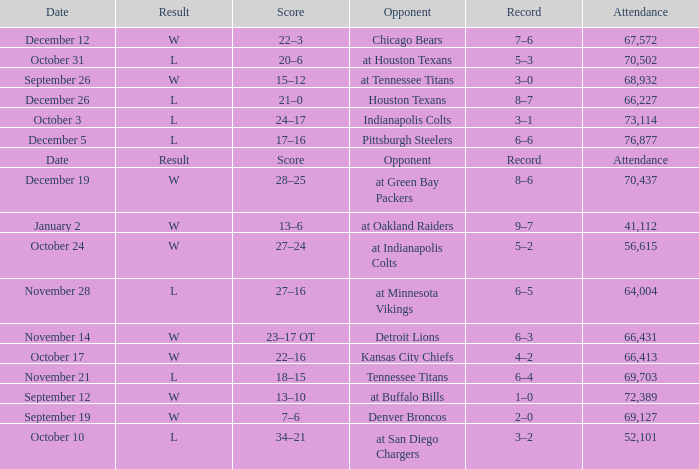What record has w as the result, with January 2 as the date? 9–7. Give me the full table as a dictionary. {'header': ['Date', 'Result', 'Score', 'Opponent', 'Record', 'Attendance'], 'rows': [['December 12', 'W', '22–3', 'Chicago Bears', '7–6', '67,572'], ['October 31', 'L', '20–6', 'at Houston Texans', '5–3', '70,502'], ['September 26', 'W', '15–12', 'at Tennessee Titans', '3–0', '68,932'], ['December 26', 'L', '21–0', 'Houston Texans', '8–7', '66,227'], ['October 3', 'L', '24–17', 'Indianapolis Colts', '3–1', '73,114'], ['December 5', 'L', '17–16', 'Pittsburgh Steelers', '6–6', '76,877'], ['Date', 'Result', 'Score', 'Opponent', 'Record', 'Attendance'], ['December 19', 'W', '28–25', 'at Green Bay Packers', '8–6', '70,437'], ['January 2', 'W', '13–6', 'at Oakland Raiders', '9–7', '41,112'], ['October 24', 'W', '27–24', 'at Indianapolis Colts', '5–2', '56,615'], ['November 28', 'L', '27–16', 'at Minnesota Vikings', '6–5', '64,004'], ['November 14', 'W', '23–17 OT', 'Detroit Lions', '6–3', '66,431'], ['October 17', 'W', '22–16', 'Kansas City Chiefs', '4–2', '66,413'], ['November 21', 'L', '18–15', 'Tennessee Titans', '6–4', '69,703'], ['September 12', 'W', '13–10', 'at Buffalo Bills', '1–0', '72,389'], ['September 19', 'W', '7–6', 'Denver Broncos', '2–0', '69,127'], ['October 10', 'L', '34–21', 'at San Diego Chargers', '3–2', '52,101']]} 